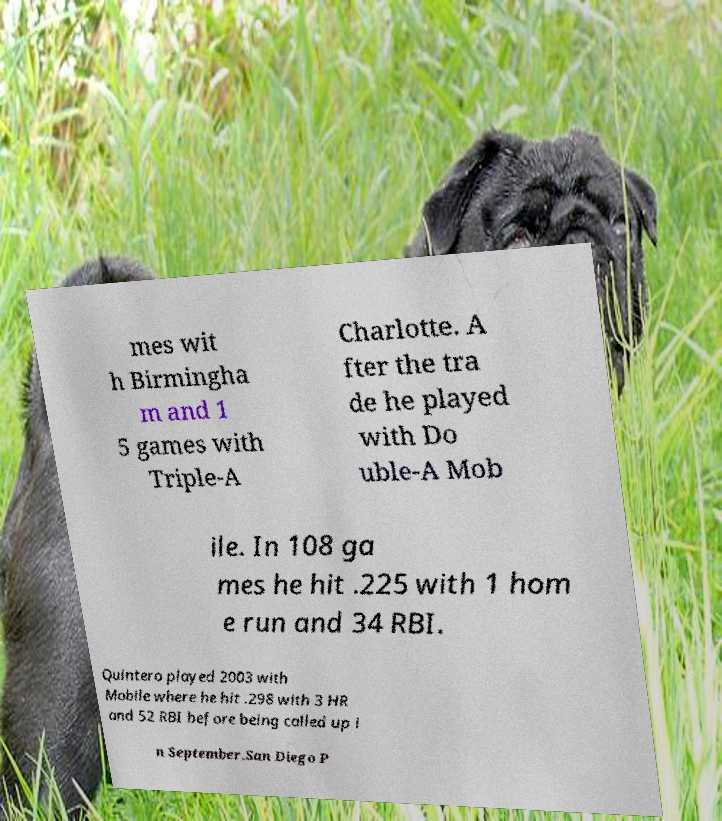Could you assist in decoding the text presented in this image and type it out clearly? mes wit h Birmingha m and 1 5 games with Triple-A Charlotte. A fter the tra de he played with Do uble-A Mob ile. In 108 ga mes he hit .225 with 1 hom e run and 34 RBI. Quintero played 2003 with Mobile where he hit .298 with 3 HR and 52 RBI before being called up i n September.San Diego P 